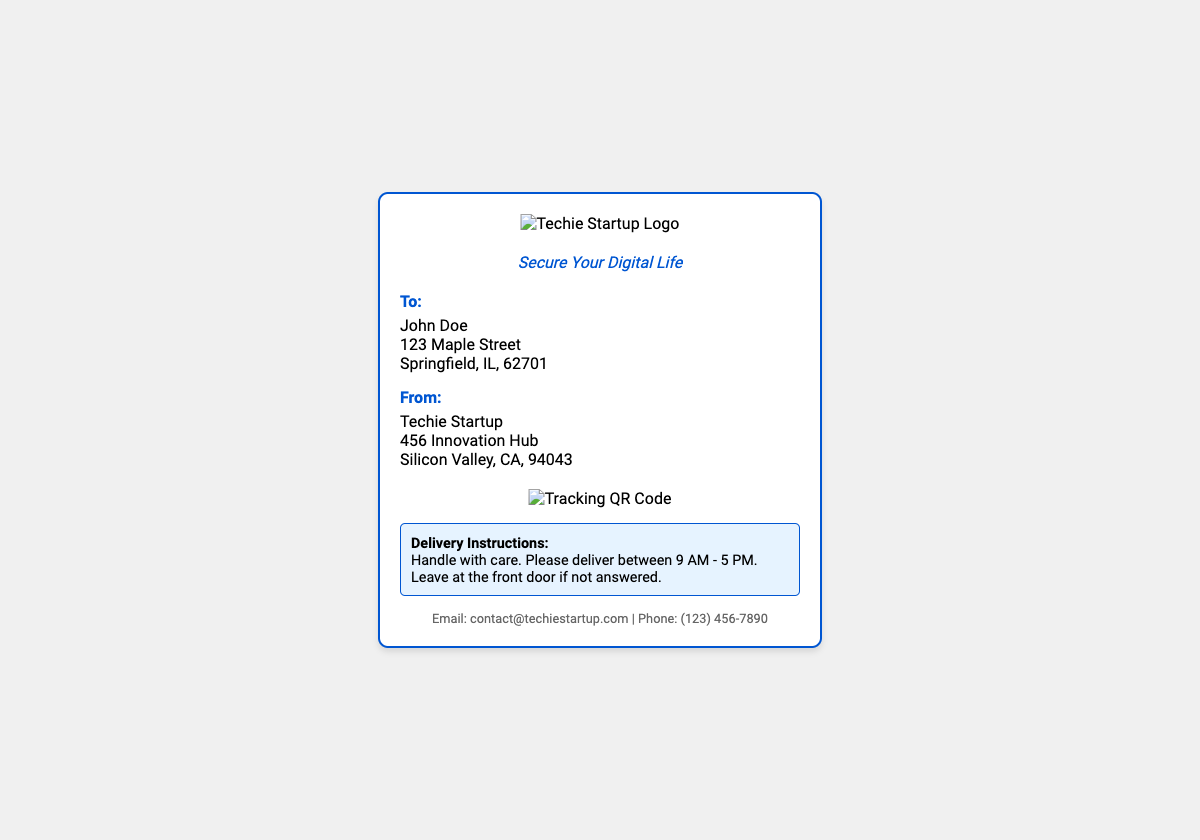What is the recipient's name? The recipient's name is listed in the "To" section of the label.
Answer: John Doe What is the sender's contact email? The sender's contact email is provided in the contact information at the bottom of the label.
Answer: contact@techiestartup.com What is the address of the sender? The sender's address can be found in the "From" section of the label.
Answer: 456 Innovation Hub, Silicon Valley, CA, 94043 What type of QR code is included? The QR code in the document is associated with tracking the package.
Answer: Tracking QR Code What are the delivery instructions? The delivery instructions specify how the package should be handled and the delivery window.
Answer: Handle with care. Please deliver between 9 AM - 5 PM. Leave at the front door if not answered How is the sender's logo displayed? The sender's logo is presented at the top section of the shipping label.
Answer: As an image What color are the brand colors highlighted in the shipping label? The document features specific colors that represent the brand visually.
Answer: Vibrant brand colors What information is required for corporate clients? The shipping label must include security-related details for corporate clients.
Answer: Authentication codes What is the tag line? The tag line for the company is present below the logo.
Answer: Secure Your Digital Life 